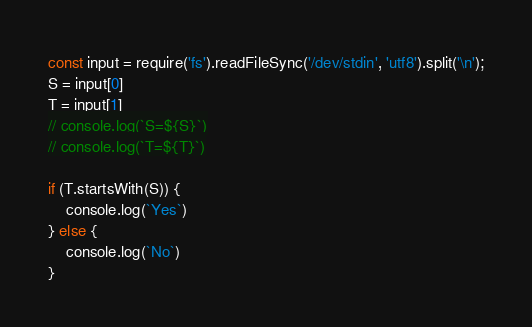Convert code to text. <code><loc_0><loc_0><loc_500><loc_500><_JavaScript_>const input = require('fs').readFileSync('/dev/stdin', 'utf8').split('\n');
S = input[0]
T = input[1]
// console.log(`S=${S}`)
// console.log(`T=${T}`)

if (T.startsWith(S)) {
    console.log(`Yes`)
} else {
    console.log(`No`)
}</code> 